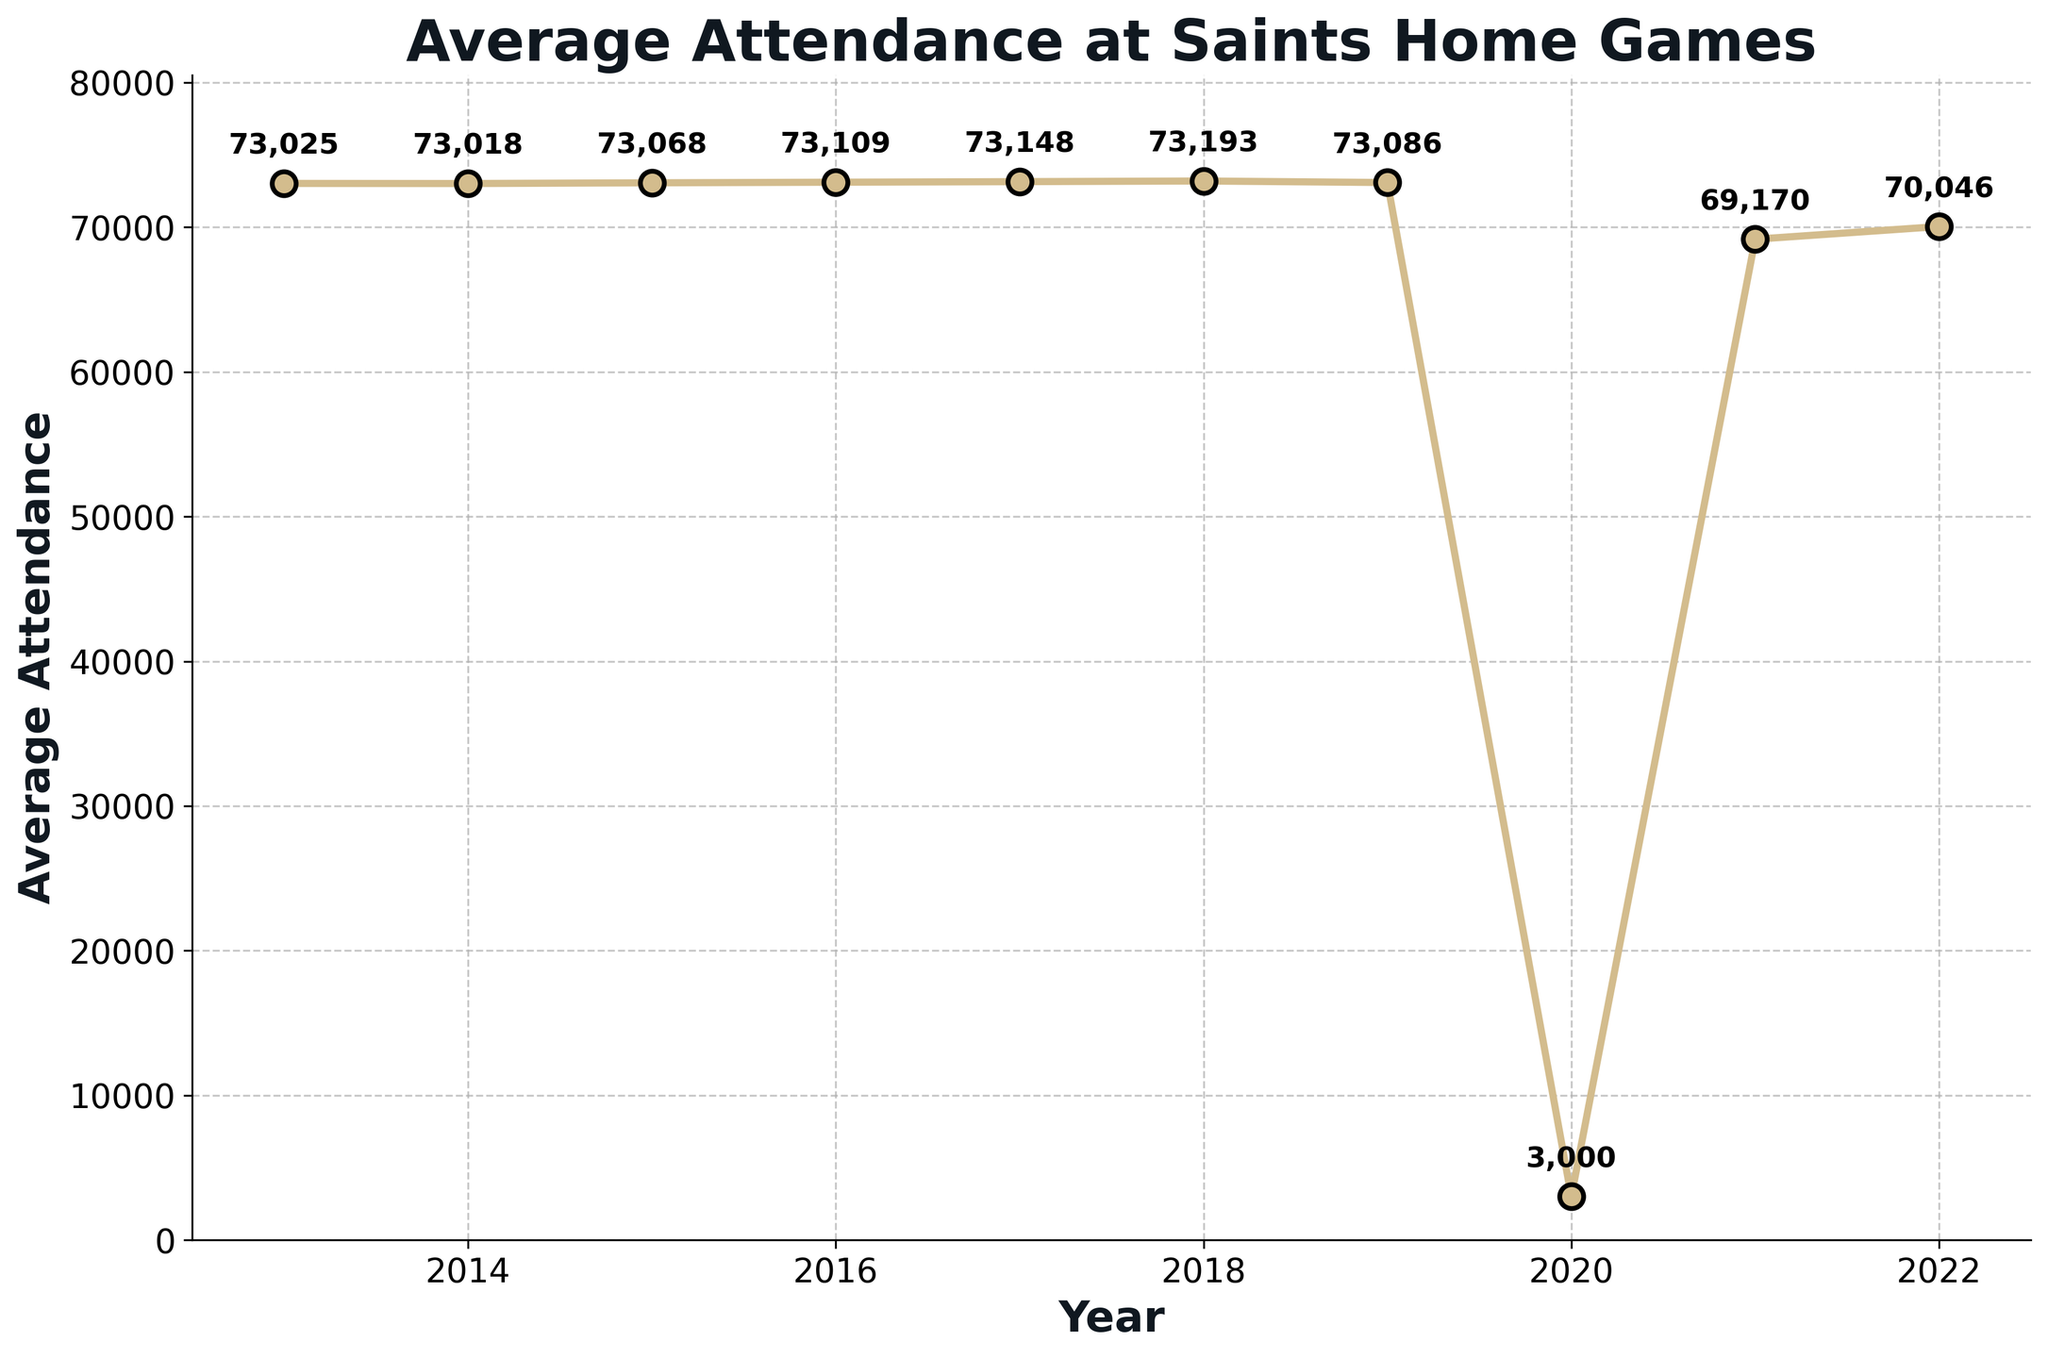What year had the highest average attendance? By examining the plot, you can see the year with the highest data point. This corresponds to 2018 with the highest average attendance value annotated on the plot.
Answer: 2018 What was the average attendance in 2020 compared to 2019? From the plot, you can see the values for 2019 and 2020. Average attendance in 2019 was 73,086 and in 2020 it was 3,000.
Answer: 2020 had a much lower attendance than 2019 How did the average attendance change from 2020 to 2021? Look at the data points for 2020 and 2021. In 2020, the average attendance was 3,000, and it increased to 69,170 in 2021.
Answer: Increased significantly Which years had average attendance of over 73,000? By inspecting the y-axis values and the corresponding data points, the years with more than 73,000 average attendance are 2013, 2014, 2015, 2016, 2017, 2018, and 2019.
Answer: 2013, 2014, 2015, 2016, 2017, 2018, 2019 What is the average attendance over the whole decade? Sum all the average attendance values and divide by the number of years. (73025+73018+73068+73109+73148+73193+73086+3000+69170+70046)/10 = 67186.3
Answer: 67,186.3 How does the trend in attendance look over the last decade? By observing the plotted line, you can see that the attendance was relatively stable with minor fluctuations until a sharp drop in 2020, followed by a partial recovery in 2021 and 2022.
Answer: Stable with a sharp dip in 2020 Which year saw the largest decrease in average attendance compared to the previous year? Compare the differences between each successive year's attendance. The largest drop occurs between 2019 (73,086) and 2020 (3,000).
Answer: 2020 Which two consecutive years had the smallest change in average attendance? Examining the differences year by year, the smallest change occurs between 2013 (73,025) and 2014 (73,018), a difference of 7.
Answer: 2013-2014 